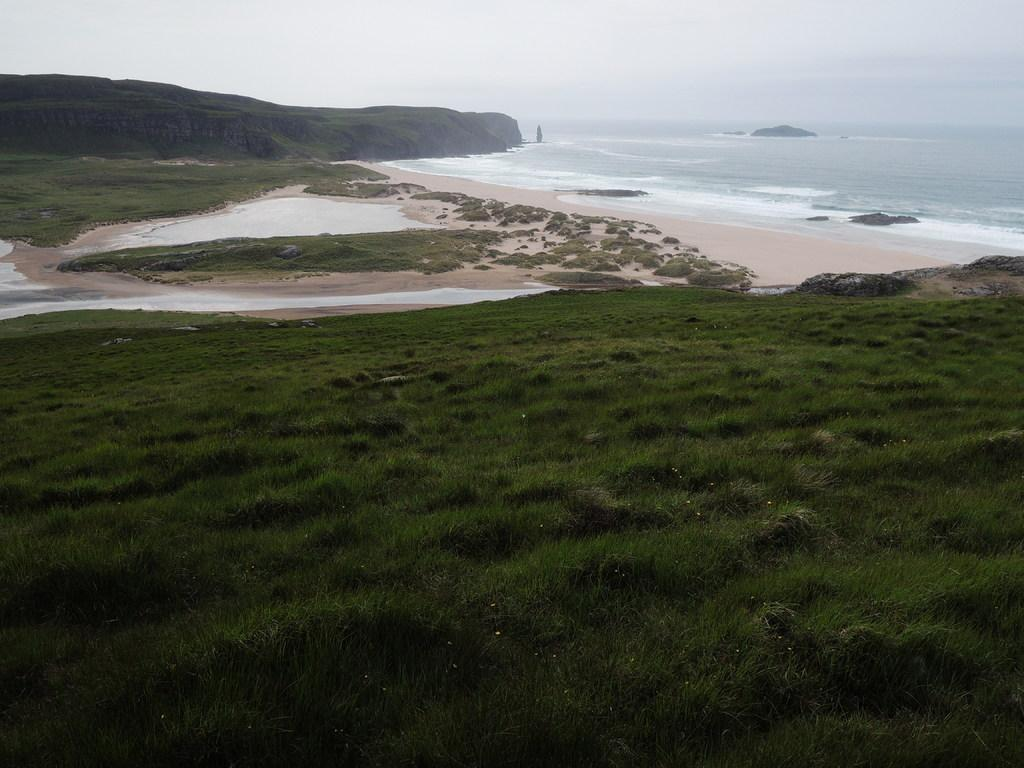What type of terrain is at the bottom of the image? There is grass at the bottom of the image. What can be seen in the background of the image? There is sky and water visible in the background of the image. What type of fear is depicted in the image? There is no fear depicted in the image; it features grass, sky, and water. What type of beam is supporting the water in the image? There is no beam present in the image; the water is visible in the background without any visible support. 